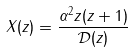Convert formula to latex. <formula><loc_0><loc_0><loc_500><loc_500>X ( z ) = \frac { \alpha ^ { 2 } z ( z + 1 ) } { \mathcal { D } ( z ) }</formula> 